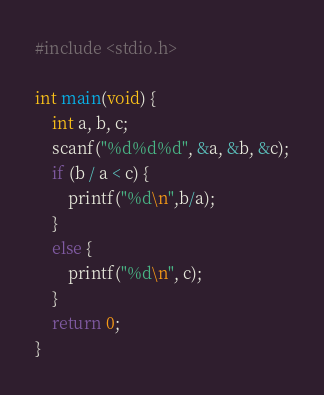<code> <loc_0><loc_0><loc_500><loc_500><_C_>#include <stdio.h>

int main(void) {
	int a, b, c;
	scanf("%d%d%d", &a, &b, &c);
	if (b / a < c) {
		printf("%d\n",b/a);
	}
	else {
		printf("%d\n", c);
	}
	return 0;
}</code> 